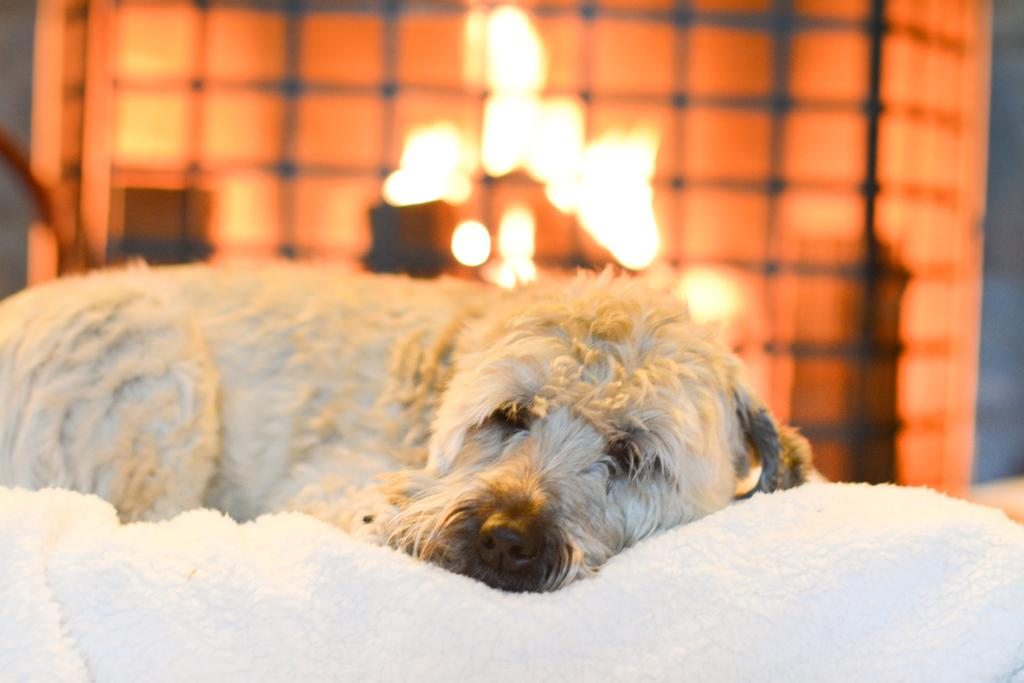What animal can be seen in the image? There is a dog in the image. What is the dog lying on? The dog is lying on a white object. What can be seen in the background of the image? There are lights and other objects visible in the background. How would you describe the background of the image? The background of the image is blurry. What type of cheese is the dog eating in the image? There is no cheese present in the image; the dog is lying on a white object. Can you hear the drum being played in the background of the image? There is no drum or sound present in the image, as it is a still photograph. 